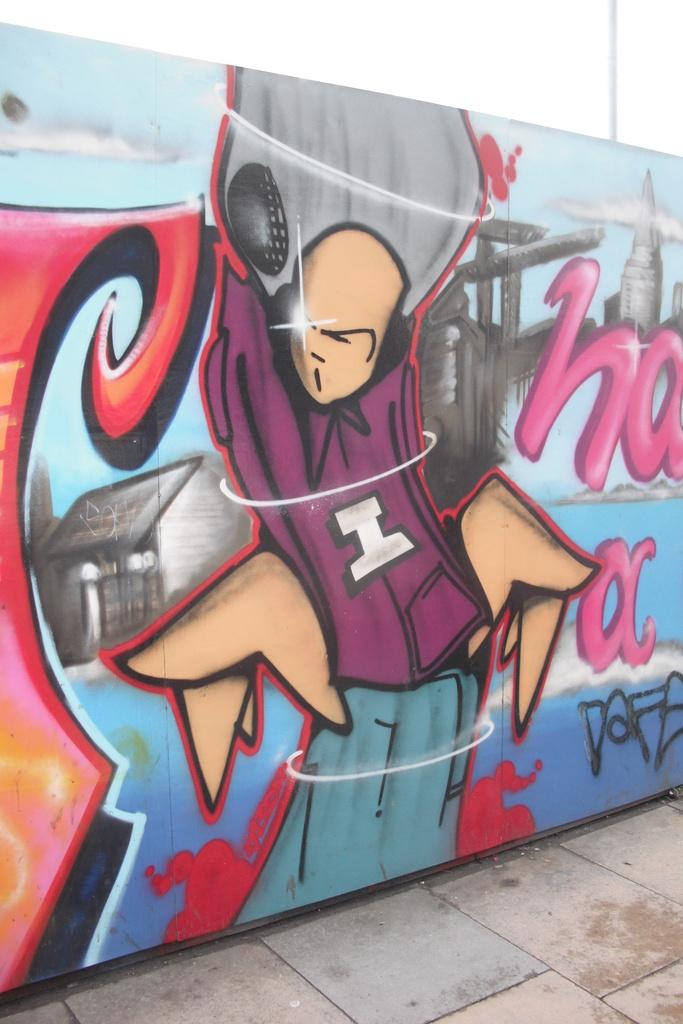What is the main subject of the image? The main subject of the image is a colorful graffiti painting on a wall. Can you describe the setting of the image? The image appears to depict a road. What type of lunchroom can be seen in the image? There is no lunchroom present in the image; it features a graffiti painting on a wall and a road. What is the condition of the graffiti painting in the image? The provided facts do not mention the condition of the graffiti painting, so we cannot determine its condition from the image. 